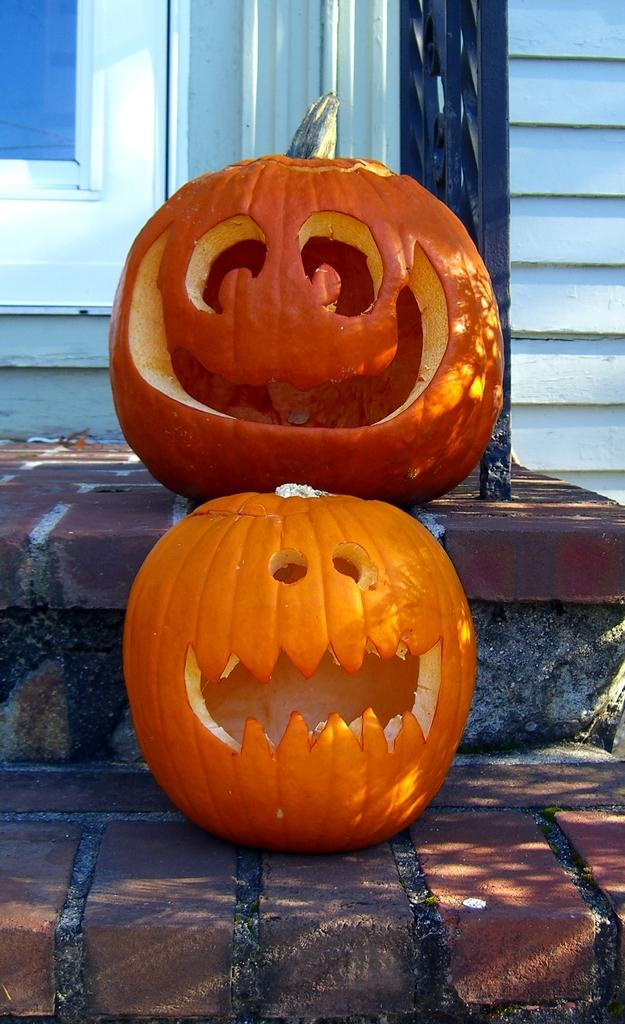What objects are on the steps in the image? There are pumpkins on the steps. What can be seen in the background of the image? There is a window, a wall, and a grill in the background. What type of vase is placed on the grill in the image? There is no vase present in the image, and the grill is not mentioned as having any objects placed on it. 